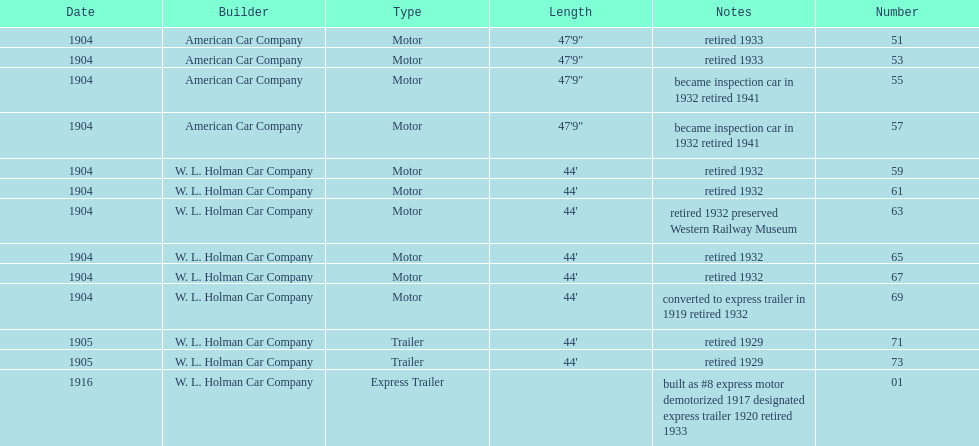In 1906, how many total rolling stock vehicles were in service? 12. 